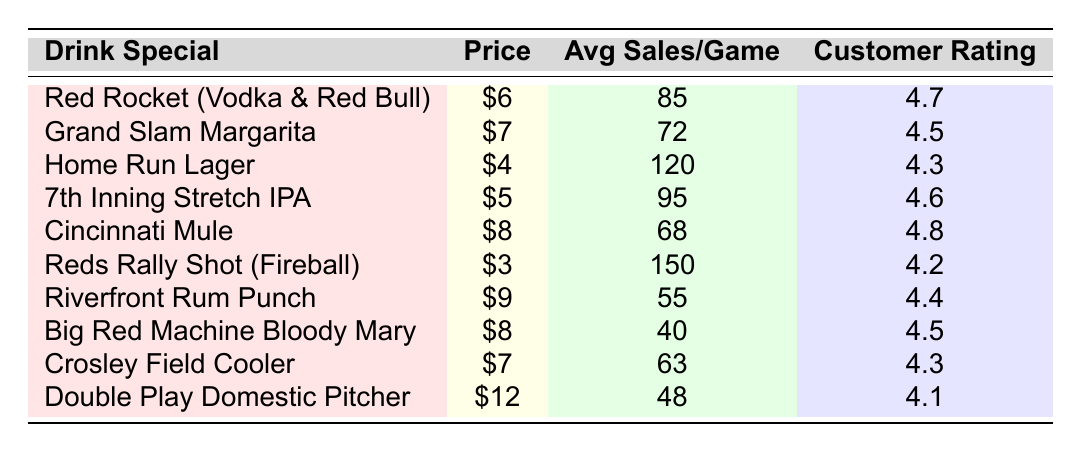What is the drink special with the highest average sales per game? The drink special with the highest average sales per game is the Reds Rally Shot (Fireball) with 150 average sales.
Answer: Reds Rally Shot (Fireball) Which drink special has the lowest price? The drink special with the lowest price is the Reds Rally Shot (Fireball), priced at $3.
Answer: $3 What is the average customer rating of the Grand Slam Margarita? The Grand Slam Margarita has an average customer rating of 4.5.
Answer: 4.5 How many drink specials have a customer rating of 4.5 or higher? By counting the rows, the drink specials with a customer rating of 4.5 or higher are Red Rocket (4.7), Grand Slam Margarita (4.5), 7th Inning Stretch IPA (4.6), Cincinnati Mule (4.8), Big Red Machine Bloody Mary (4.5), and Crosley Field Cooler (4.3), totaling 6 special drinks.
Answer: 6 What is the price difference between the most expensive and cheapest drink specials? The most expensive drink special is the Double Play Domestic Pitcher at $12, and the cheapest is the Reds Rally Shot at $3, so the price difference is $12 - $3 = $9.
Answer: $9 Compute the total average sales for all drink specials. By summing the average sales: 85 + 72 + 120 + 95 + 68 + 150 + 55 + 40 + 63 + 48 = 696. Thus, the total average sales for all drinks is 696.
Answer: 696 Is the Cincinnati Mule rated higher than the Home Run Lager? The Cincinnati Mule has a customer rating of 4.8, while the Home Run Lager has a rating of 4.3, therefore the Cincinnati Mule is rated higher.
Answer: Yes Which drink special has the second lowest average sales per game? The drink special with the second lowest average sales per game is the Big Red Machine Bloody Mary with 40 average sales, as the lowest is the Riverfront Rum Punch with 55.
Answer: Big Red Machine Bloody Mary How many drink specials are priced above $6? The drink specials priced above $6 are Cincinnati Mule ($8), Riverfront Rum Punch ($9), and Double Play Domestic Pitcher ($12), totaling 3 specials over $6.
Answer: 3 What is the average price of all drink specials? The prices of the drink specials are $6, $7, $4, $5, $8, $3, $9, $8, $7, $12. Adding these together gives $6 + $7 + $4 + $5 + $8 + $3 + $9 + $8 + $7 + $12 = 69. Dividing this by the number of specials (10) gives an average of $69/10 = $6.9.
Answer: $6.9 